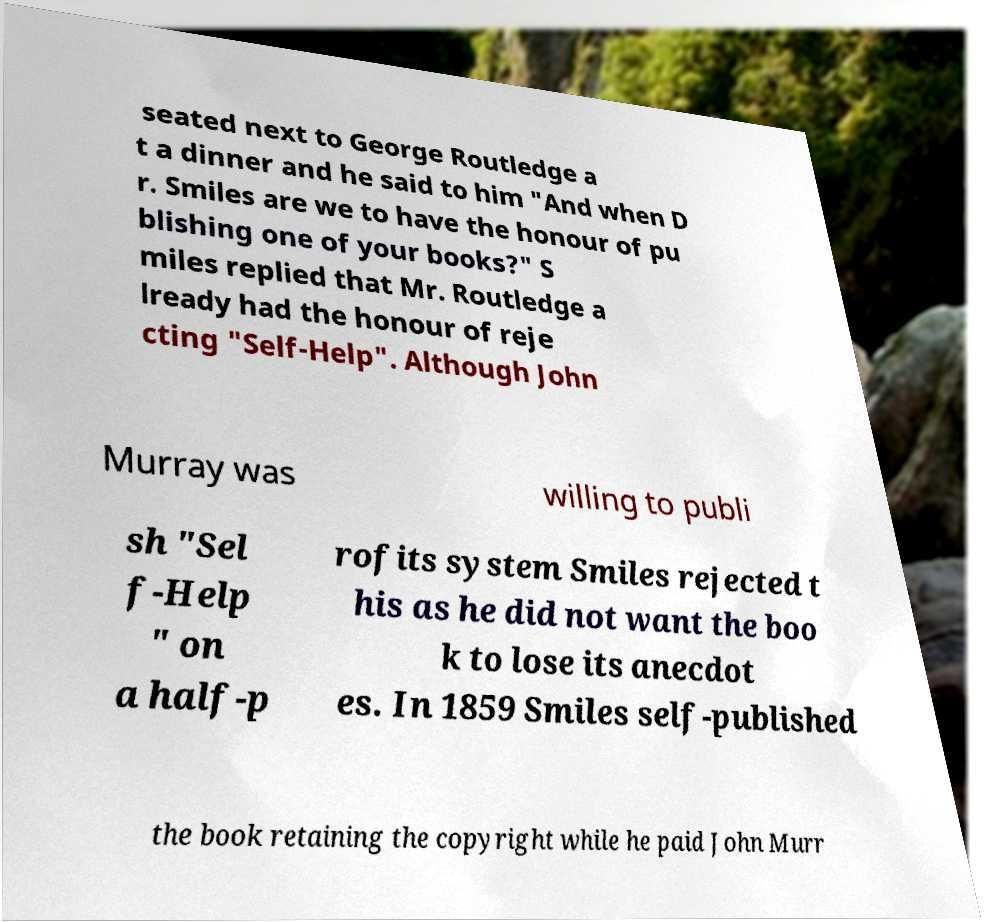What messages or text are displayed in this image? I need them in a readable, typed format. seated next to George Routledge a t a dinner and he said to him "And when D r. Smiles are we to have the honour of pu blishing one of your books?" S miles replied that Mr. Routledge a lready had the honour of reje cting "Self-Help". Although John Murray was willing to publi sh "Sel f-Help " on a half-p rofits system Smiles rejected t his as he did not want the boo k to lose its anecdot es. In 1859 Smiles self-published the book retaining the copyright while he paid John Murr 